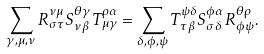<formula> <loc_0><loc_0><loc_500><loc_500>\sum _ { \gamma , \mu , \nu } R _ { \sigma \tau } ^ { \nu \mu } S _ { \nu \beta } ^ { \theta \gamma } T _ { \mu \gamma } ^ { \rho \alpha } = \sum _ { \delta , \phi , \psi } T _ { \tau \beta } ^ { \psi \delta } S _ { \sigma \delta } ^ { \phi \alpha } R _ { \phi \psi } ^ { \theta \rho } .</formula> 